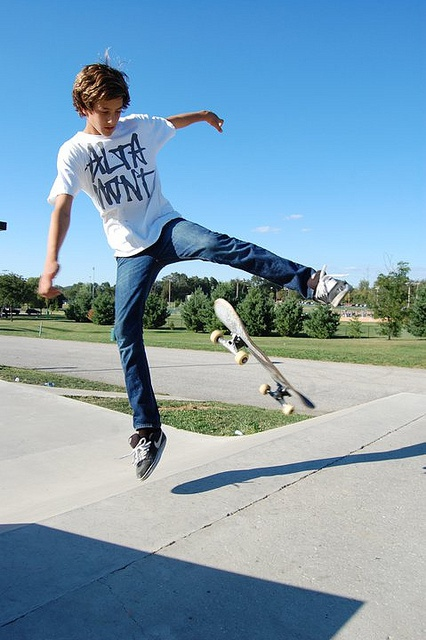Describe the objects in this image and their specific colors. I can see people in gray, black, white, and darkgray tones and skateboard in gray, lightgray, darkgray, and black tones in this image. 